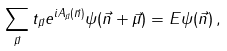Convert formula to latex. <formula><loc_0><loc_0><loc_500><loc_500>\sum _ { \vec { \mu } } t _ { \vec { \mu } } e ^ { i A _ { \vec { \mu } } ( \vec { n } ) } \psi ( \vec { n } + \vec { \mu } ) = E \psi ( \vec { n } ) \, ,</formula> 